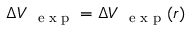Convert formula to latex. <formula><loc_0><loc_0><loc_500><loc_500>\Delta V _ { e x p } = \Delta V _ { e x p } ( r )</formula> 